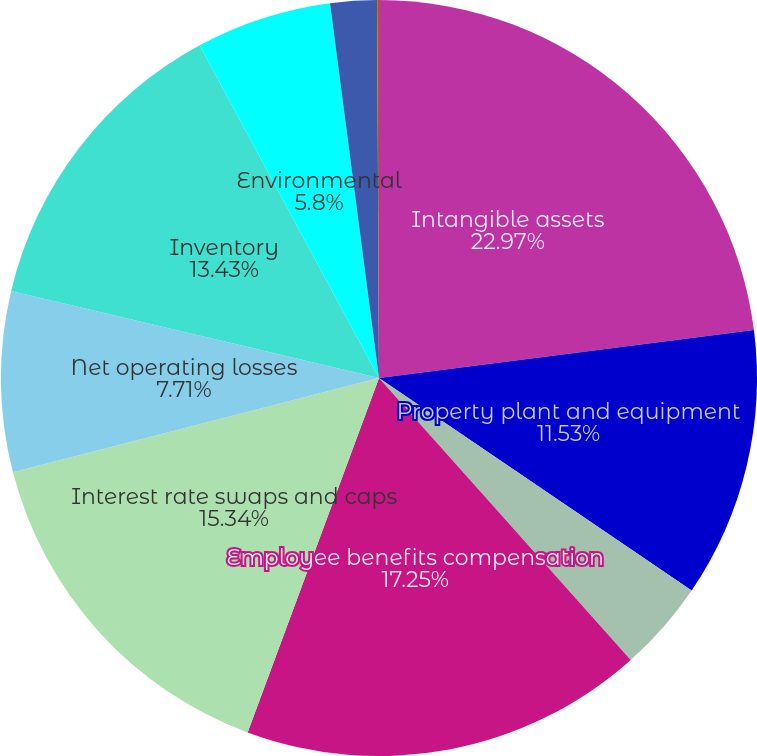<chart> <loc_0><loc_0><loc_500><loc_500><pie_chart><fcel>Intangible assets<fcel>Property plant and equipment<fcel>Unremitted foreign earnings<fcel>Employee benefits compensation<fcel>Interest rate swaps and caps<fcel>Net operating losses<fcel>Inventory<fcel>Environmental<fcel>Product warranties<fcel>Other<nl><fcel>22.97%<fcel>11.53%<fcel>3.9%<fcel>17.25%<fcel>15.34%<fcel>7.71%<fcel>13.43%<fcel>5.8%<fcel>1.99%<fcel>0.08%<nl></chart> 